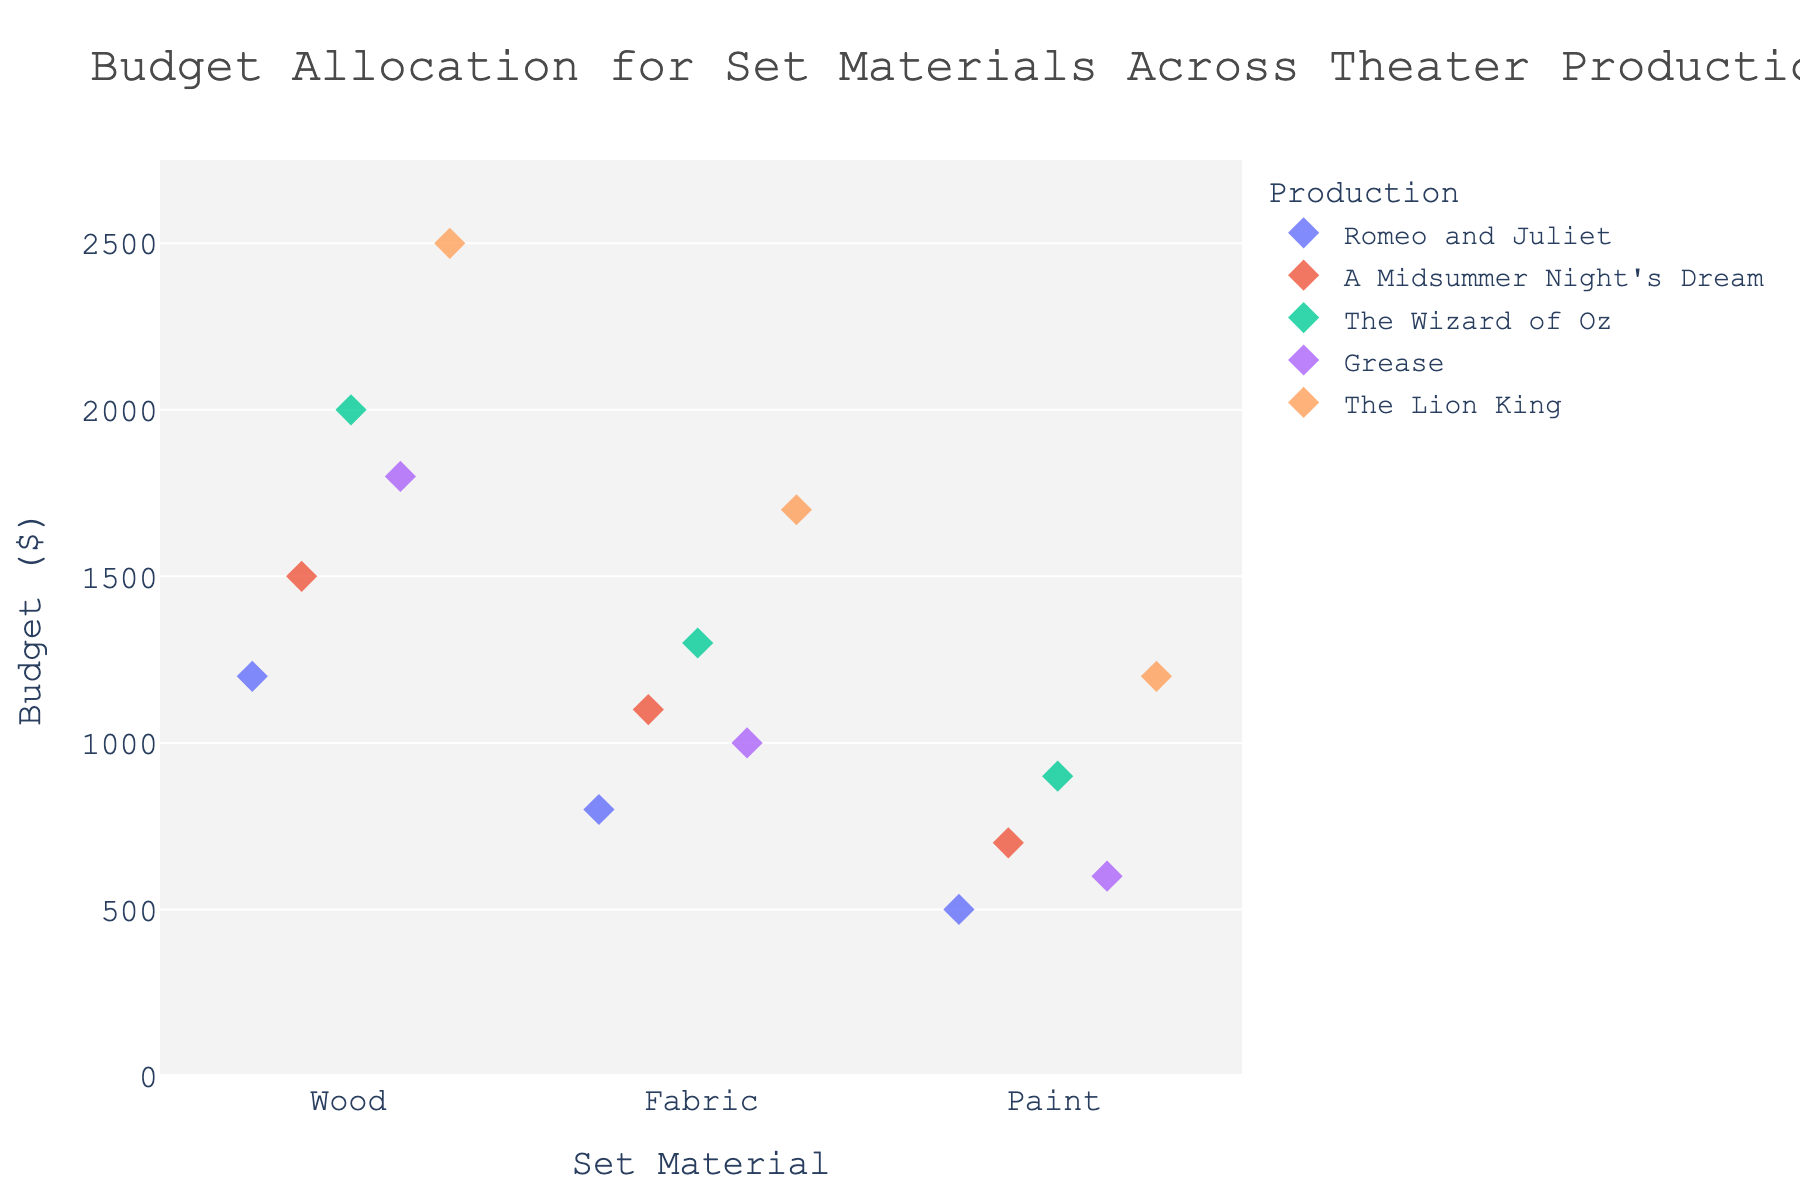What's the title of the figure? The title is usually displayed prominently at the top of the figure.
Answer: "Budget Allocation for Set Materials Across Theater Productions" How many productions are represented in the plot? Each production is represented by a unique color and are listed under the legend.
Answer: 5 Which set material has the highest budget across all productions? Check the highest point's value on the y-axis under each set material.
Answer: Wood Which production allocated the most for fabric? Find the highest point in the Fabric category and read its corresponding production from the legend.
Answer: The Lion King What is the lowest budget allocated for paint, and which production does it belong to? Locate the lowest point in the Paint category and read its y-value and the corresponding production.
Answer: $500, Romeo and Juliet What is the average budget for wood across all productions? Sum the budgets for Wood and divide by the number of productions.
Answer: (1200 + 1500 + 2000 + 1800 + 2500) / 5 = 1800 Compare the budget allocations for fabric in "Romeo and Juliet" and "A Midsummer Night's Dream." Which production allocated a higher budget? Compare the Fabric budget values for both productions directly.
Answer: A Midsummer Night's Dream How does the budget spread differ between wood and fabric across productions? Observe the range (spread) of budgets by looking at the highest and lowest points for Wood and Fabric categories.
Answer: Wood has a wider budget range than Fabric Which production has the largest total budget across all materials? Sum the budgets for Wood, Fabric, and Paint for each production and compare the totals.
Answer: The Lion King What is the difference between the highest and lowest budget for paint across all productions? Subtract the lowest budget value of Paint from the highest one.
Answer: $1200 - $500 = $700 